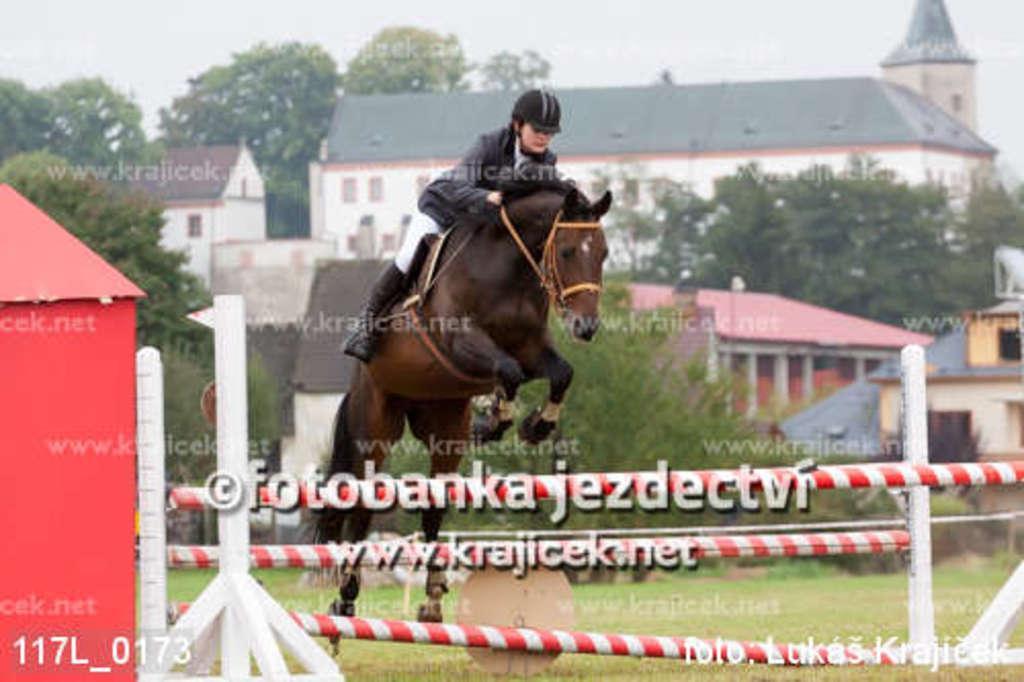How would you summarize this image in a sentence or two? In this image in the front there is a hurdle and there is a person riding a horse. In the background there are trees, houses and there's grass on the ground. In the front on the left side there is an object which is red in colour and there is some text written on the image and the sky is cloudy. 